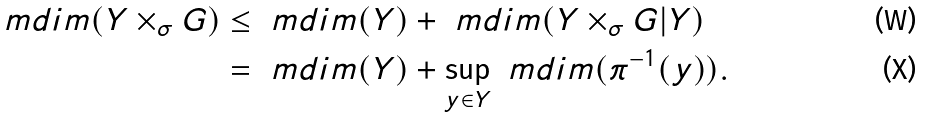<formula> <loc_0><loc_0><loc_500><loc_500>\ m d i m ( Y \times _ { \sigma } G ) & \leq \ m d i m ( Y ) + \ m d i m ( Y \times _ { \sigma } G | Y ) \\ & = \ m d i m ( Y ) + \sup _ { y \in Y } \ m d i m ( \pi ^ { - 1 } ( y ) ) .</formula> 